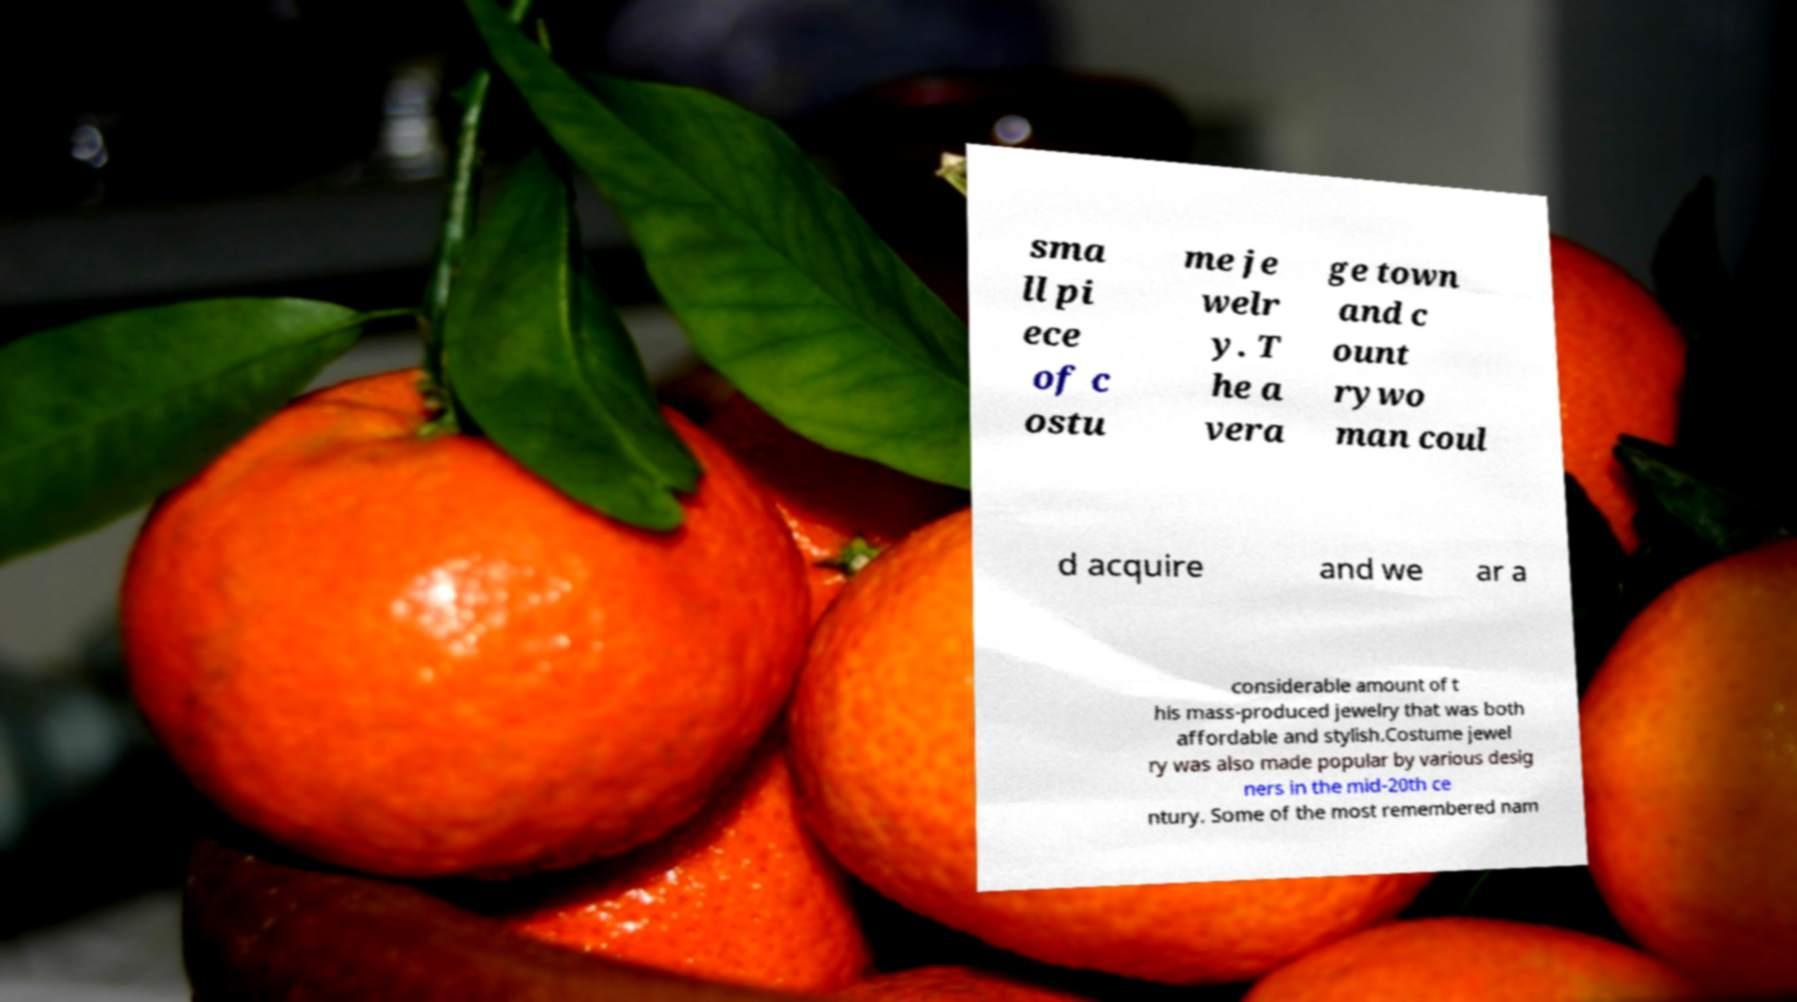There's text embedded in this image that I need extracted. Can you transcribe it verbatim? sma ll pi ece of c ostu me je welr y. T he a vera ge town and c ount rywo man coul d acquire and we ar a considerable amount of t his mass-produced jewelry that was both affordable and stylish.Costume jewel ry was also made popular by various desig ners in the mid-20th ce ntury. Some of the most remembered nam 